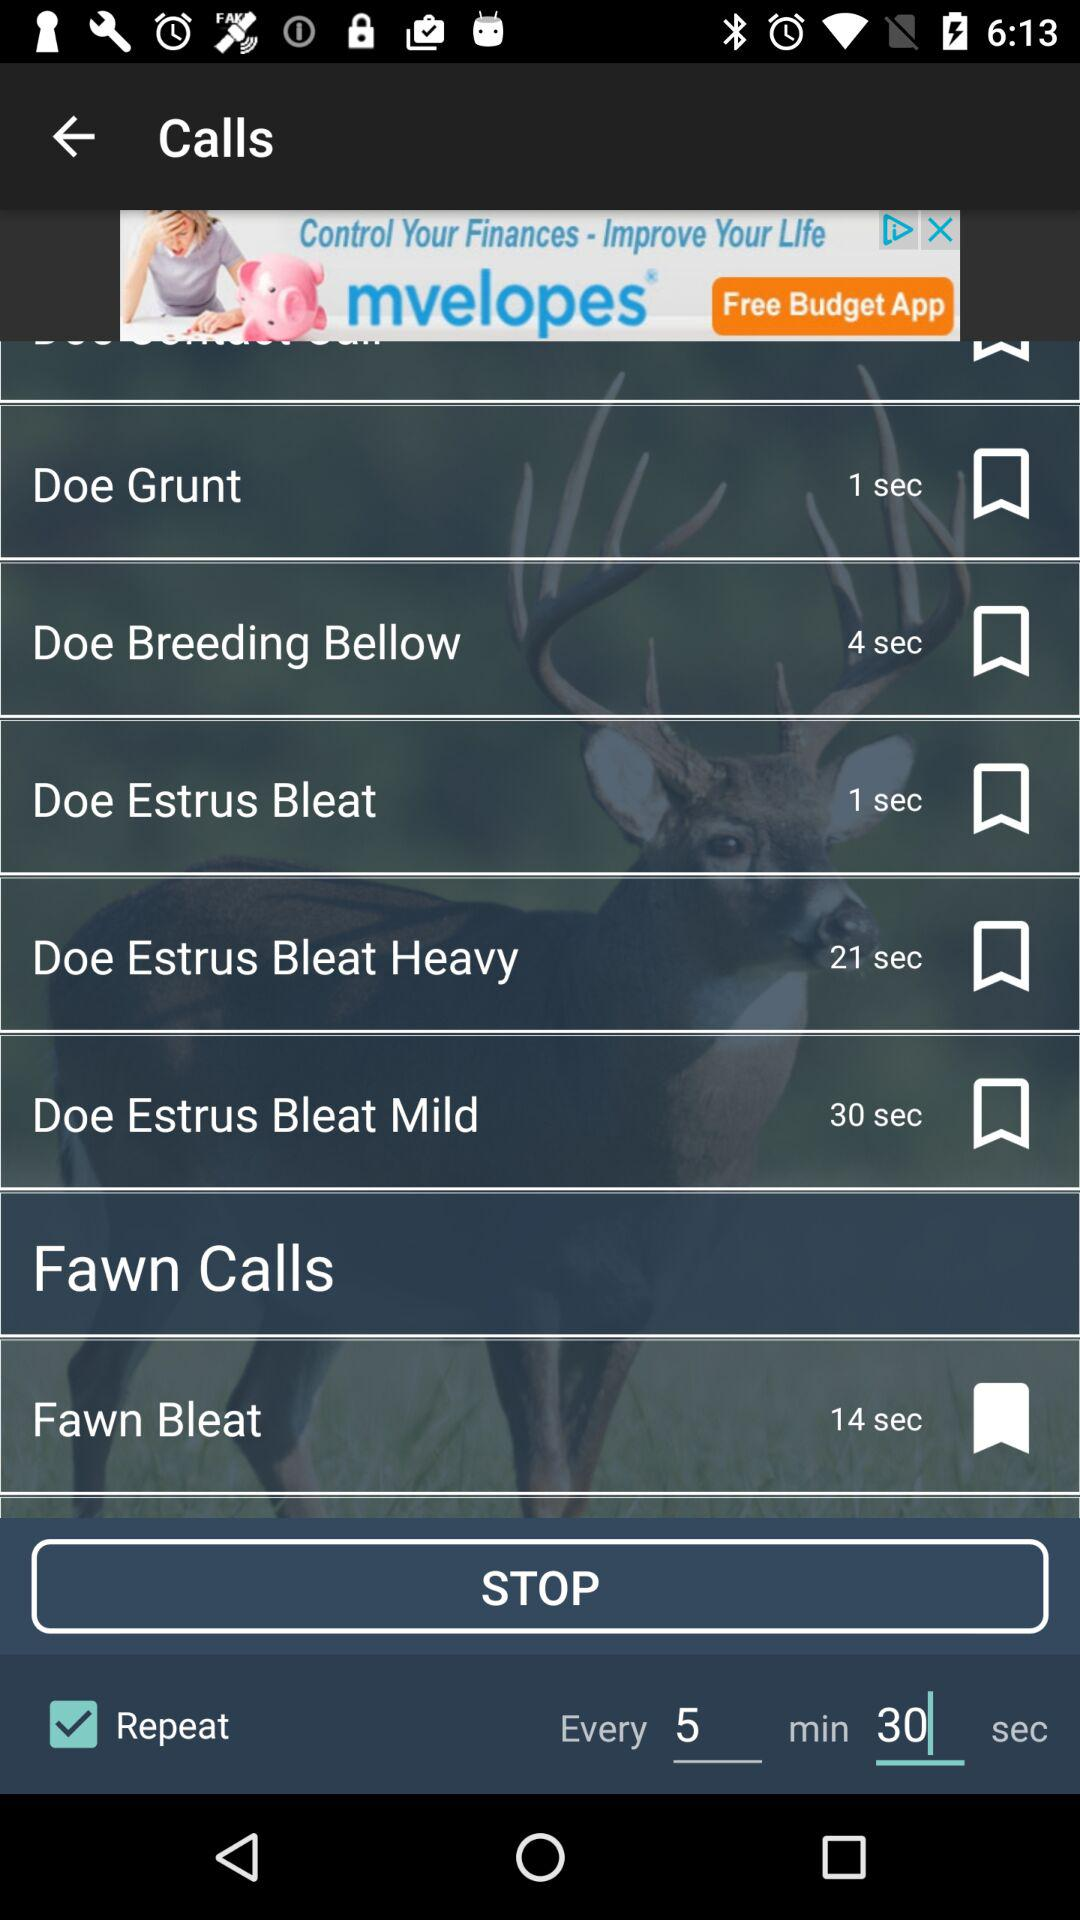What time is set for the repetition? The repetition time is every 5 minutes and 30 seconds. 